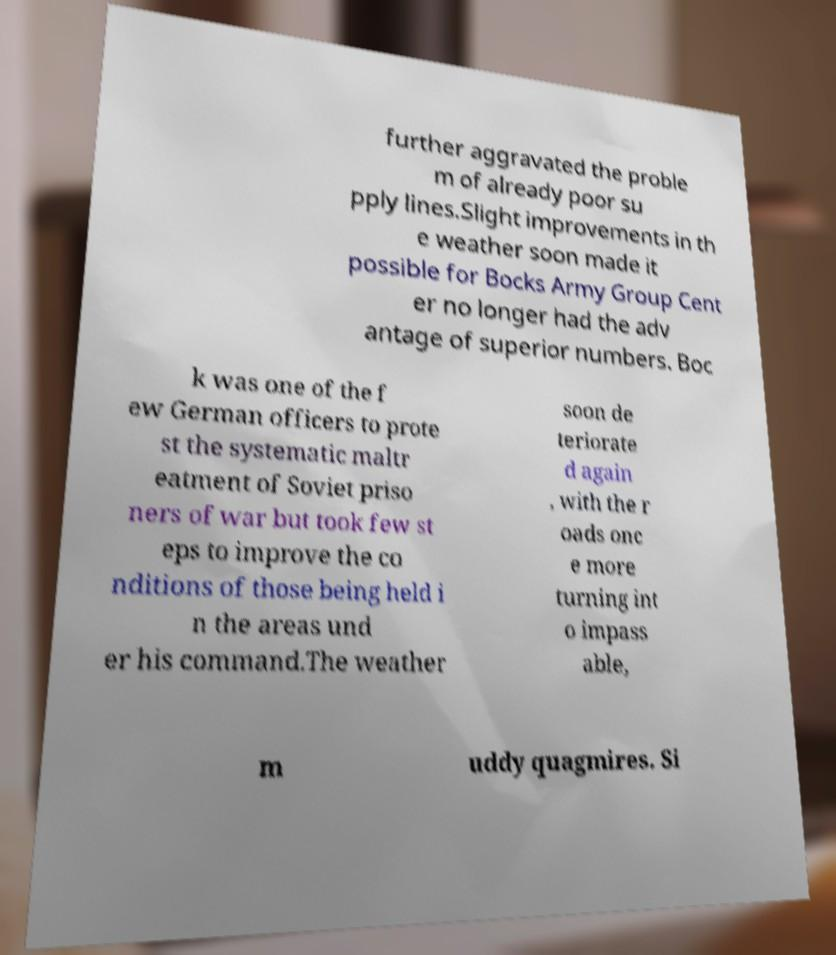I need the written content from this picture converted into text. Can you do that? further aggravated the proble m of already poor su pply lines.Slight improvements in th e weather soon made it possible for Bocks Army Group Cent er no longer had the adv antage of superior numbers. Boc k was one of the f ew German officers to prote st the systematic maltr eatment of Soviet priso ners of war but took few st eps to improve the co nditions of those being held i n the areas und er his command.The weather soon de teriorate d again , with the r oads onc e more turning int o impass able, m uddy quagmires. Si 